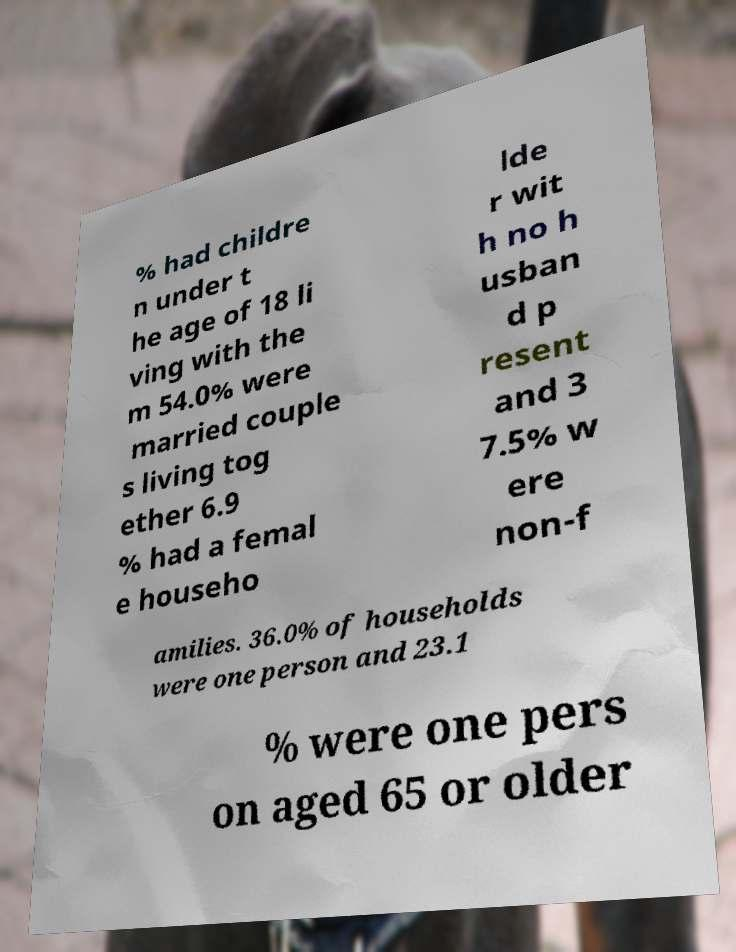I need the written content from this picture converted into text. Can you do that? % had childre n under t he age of 18 li ving with the m 54.0% were married couple s living tog ether 6.9 % had a femal e househo lde r wit h no h usban d p resent and 3 7.5% w ere non-f amilies. 36.0% of households were one person and 23.1 % were one pers on aged 65 or older 